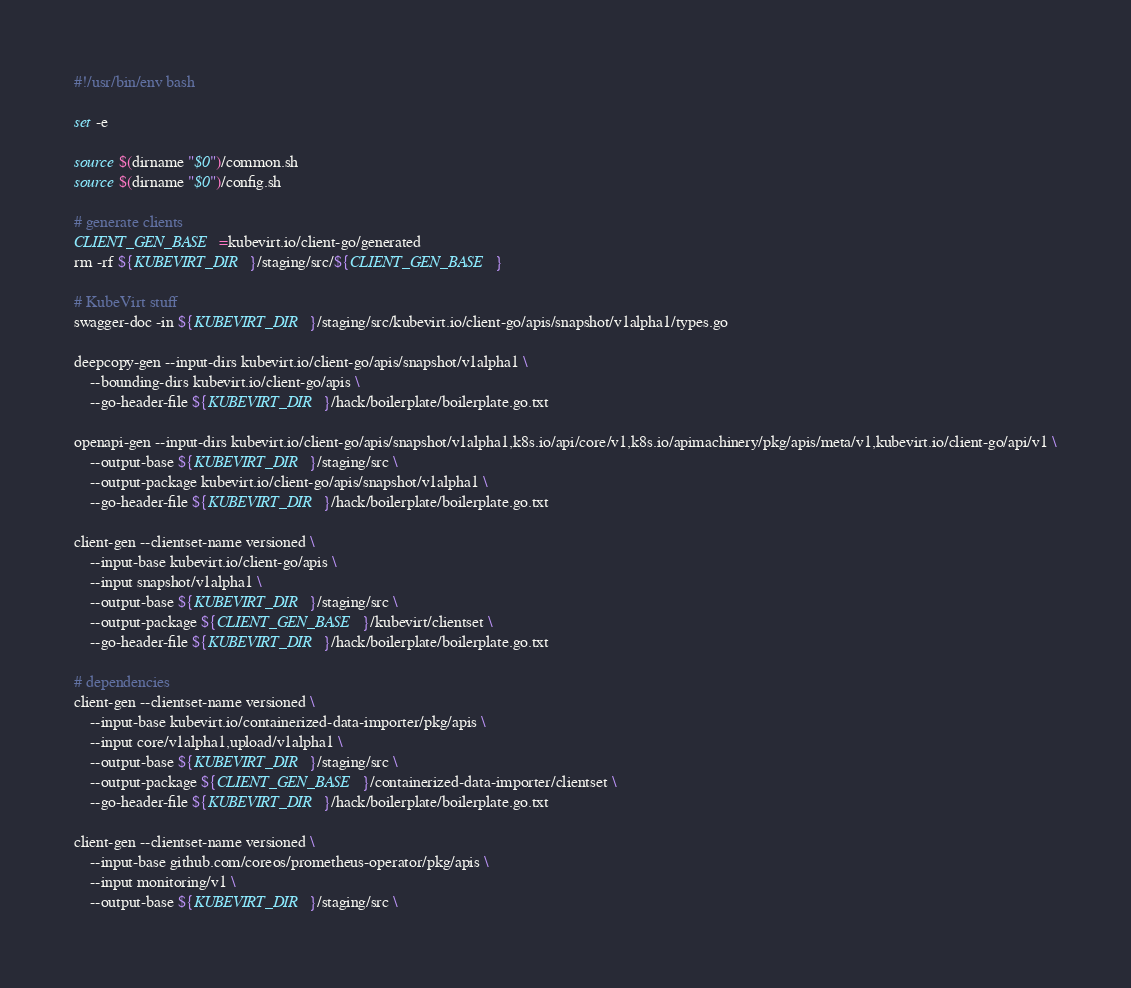Convert code to text. <code><loc_0><loc_0><loc_500><loc_500><_Bash_>#!/usr/bin/env bash

set -e

source $(dirname "$0")/common.sh
source $(dirname "$0")/config.sh

# generate clients
CLIENT_GEN_BASE=kubevirt.io/client-go/generated
rm -rf ${KUBEVIRT_DIR}/staging/src/${CLIENT_GEN_BASE}

# KubeVirt stuff
swagger-doc -in ${KUBEVIRT_DIR}/staging/src/kubevirt.io/client-go/apis/snapshot/v1alpha1/types.go

deepcopy-gen --input-dirs kubevirt.io/client-go/apis/snapshot/v1alpha1 \
    --bounding-dirs kubevirt.io/client-go/apis \
    --go-header-file ${KUBEVIRT_DIR}/hack/boilerplate/boilerplate.go.txt

openapi-gen --input-dirs kubevirt.io/client-go/apis/snapshot/v1alpha1,k8s.io/api/core/v1,k8s.io/apimachinery/pkg/apis/meta/v1,kubevirt.io/client-go/api/v1 \
    --output-base ${KUBEVIRT_DIR}/staging/src \
    --output-package kubevirt.io/client-go/apis/snapshot/v1alpha1 \
    --go-header-file ${KUBEVIRT_DIR}/hack/boilerplate/boilerplate.go.txt

client-gen --clientset-name versioned \
    --input-base kubevirt.io/client-go/apis \
    --input snapshot/v1alpha1 \
    --output-base ${KUBEVIRT_DIR}/staging/src \
    --output-package ${CLIENT_GEN_BASE}/kubevirt/clientset \
    --go-header-file ${KUBEVIRT_DIR}/hack/boilerplate/boilerplate.go.txt

# dependencies
client-gen --clientset-name versioned \
    --input-base kubevirt.io/containerized-data-importer/pkg/apis \
    --input core/v1alpha1,upload/v1alpha1 \
    --output-base ${KUBEVIRT_DIR}/staging/src \
    --output-package ${CLIENT_GEN_BASE}/containerized-data-importer/clientset \
    --go-header-file ${KUBEVIRT_DIR}/hack/boilerplate/boilerplate.go.txt

client-gen --clientset-name versioned \
    --input-base github.com/coreos/prometheus-operator/pkg/apis \
    --input monitoring/v1 \
    --output-base ${KUBEVIRT_DIR}/staging/src \</code> 